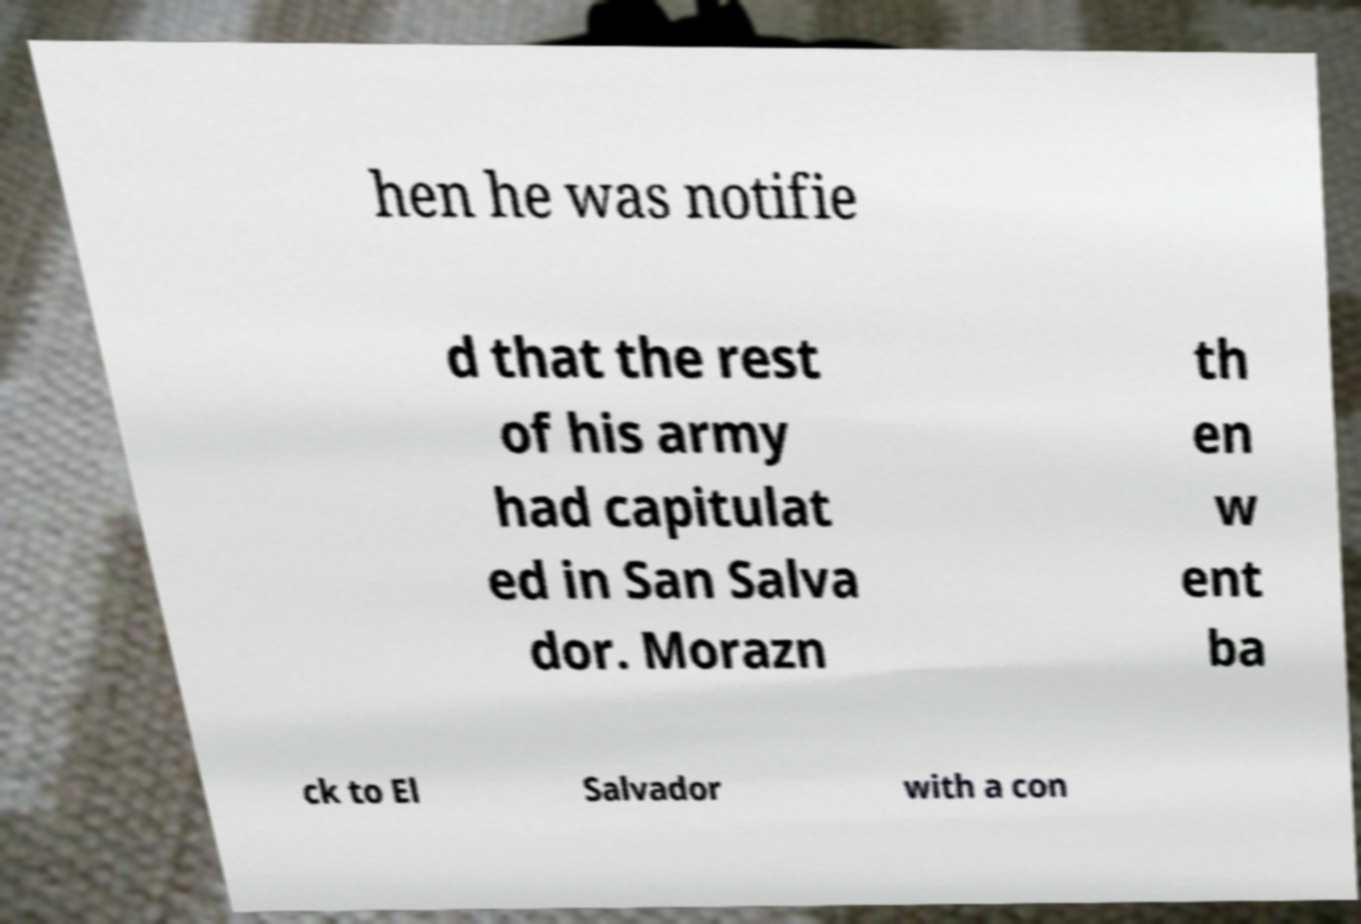I need the written content from this picture converted into text. Can you do that? hen he was notifie d that the rest of his army had capitulat ed in San Salva dor. Morazn th en w ent ba ck to El Salvador with a con 